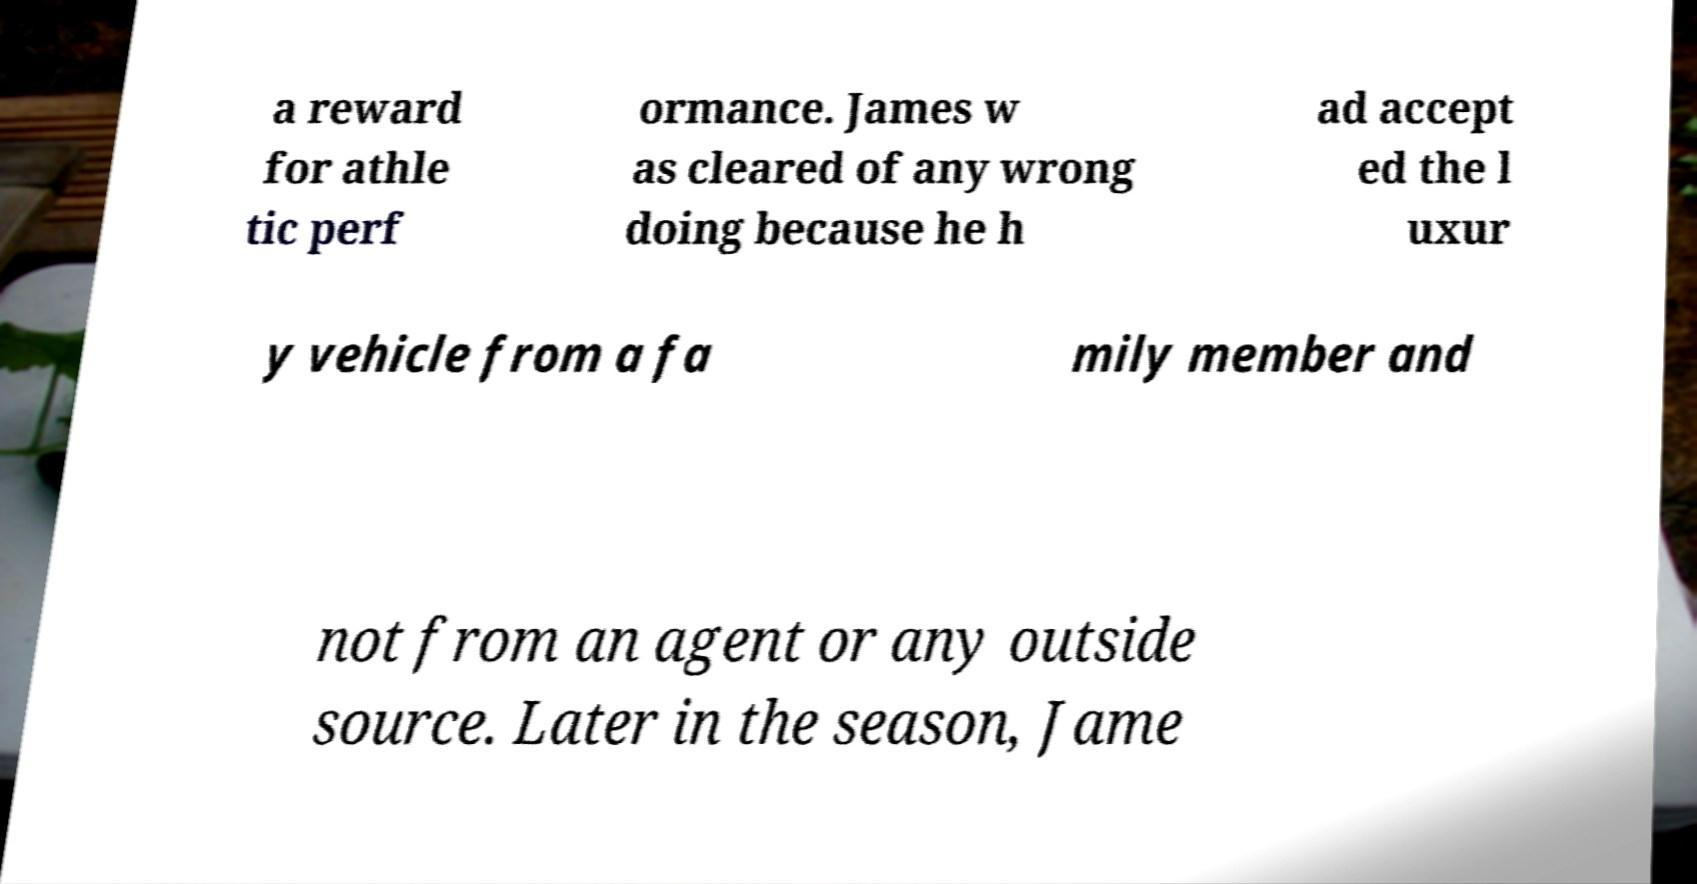I need the written content from this picture converted into text. Can you do that? a reward for athle tic perf ormance. James w as cleared of any wrong doing because he h ad accept ed the l uxur y vehicle from a fa mily member and not from an agent or any outside source. Later in the season, Jame 